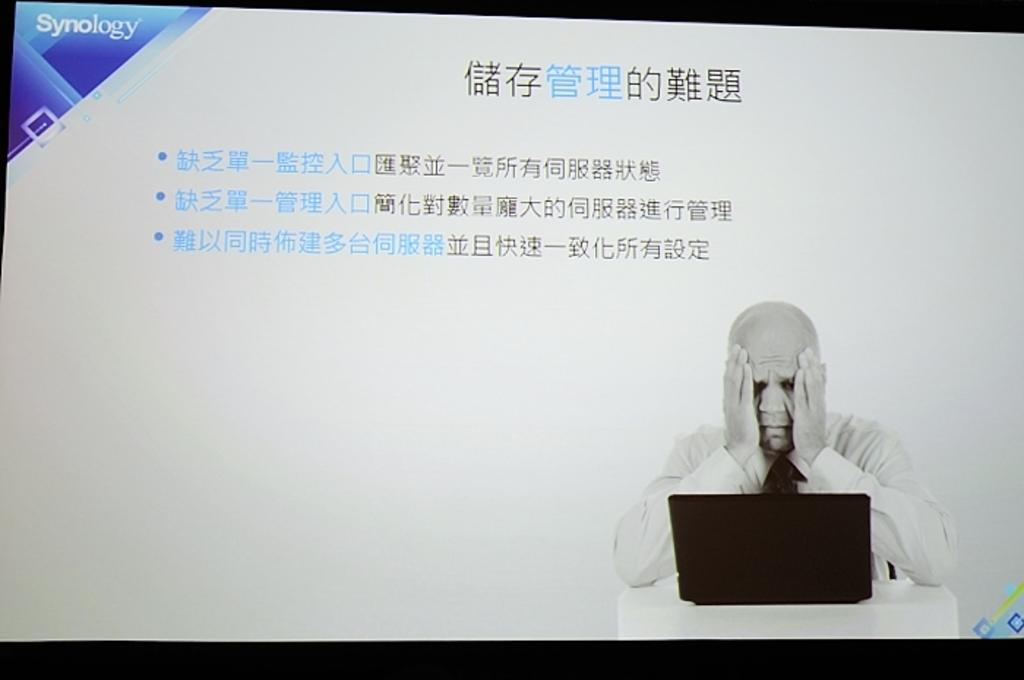What is the main object in the image? There is a screen in the image. What can be seen on the screen? Text is visible on the screen. What is the person in the image doing? The person is in-front of a laptop. What color is the background of the image? The background of the image is black. How many rabbits can be seen in the image? There are no rabbits present in the image. What color is the pest crawling on the screen? There is no pest visible on the screen in the image. 